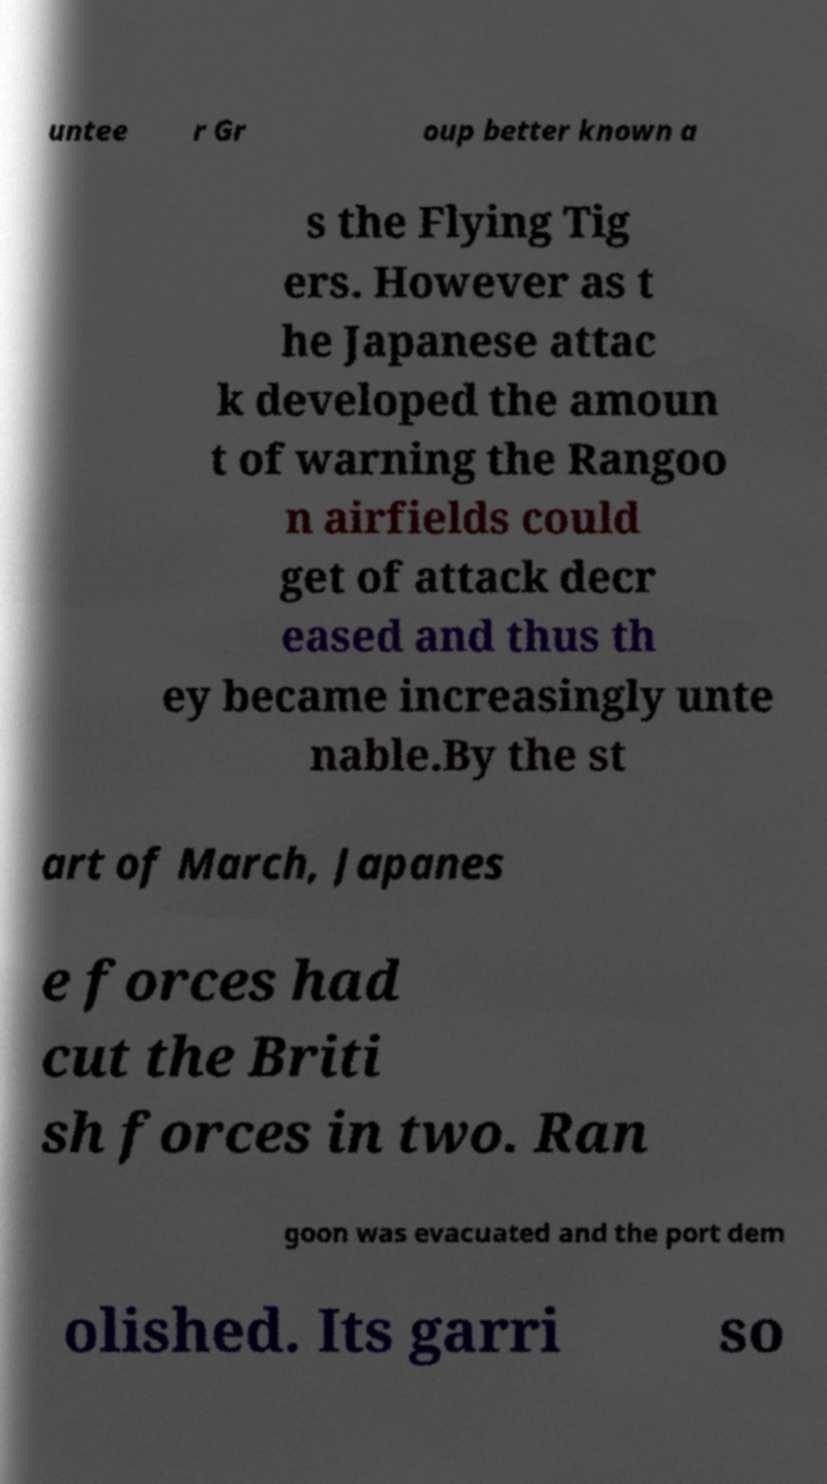There's text embedded in this image that I need extracted. Can you transcribe it verbatim? untee r Gr oup better known a s the Flying Tig ers. However as t he Japanese attac k developed the amoun t of warning the Rangoo n airfields could get of attack decr eased and thus th ey became increasingly unte nable.By the st art of March, Japanes e forces had cut the Briti sh forces in two. Ran goon was evacuated and the port dem olished. Its garri so 